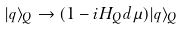<formula> <loc_0><loc_0><loc_500><loc_500>| q \rangle _ { Q } \rightarrow ( 1 - i H _ { Q } d \mu ) | q \rangle _ { Q }</formula> 